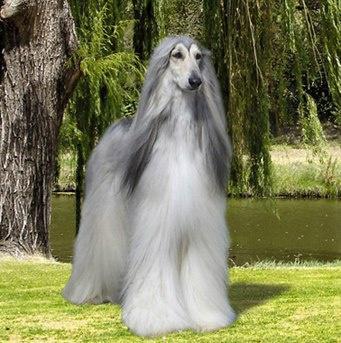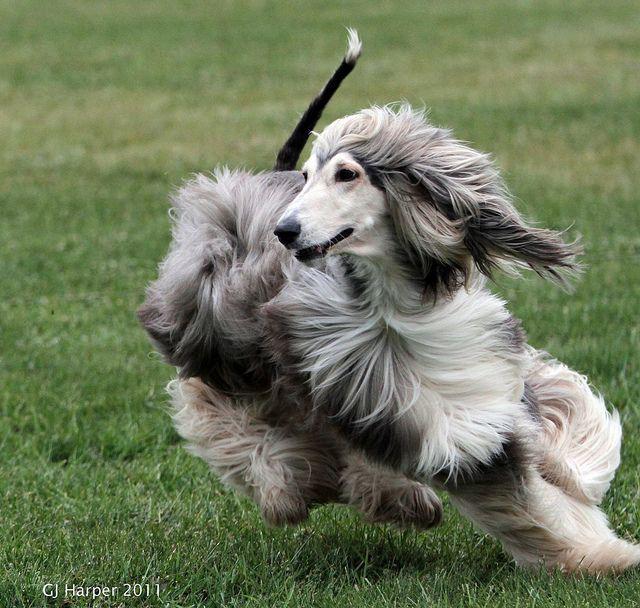The first image is the image on the left, the second image is the image on the right. Considering the images on both sides, is "In one image there is a lone afghan hound sitting outside in the grass." valid? Answer yes or no. No. The first image is the image on the left, the second image is the image on the right. Examine the images to the left and right. Is the description "One image has a dog facing left but looking to the right." accurate? Answer yes or no. No. 